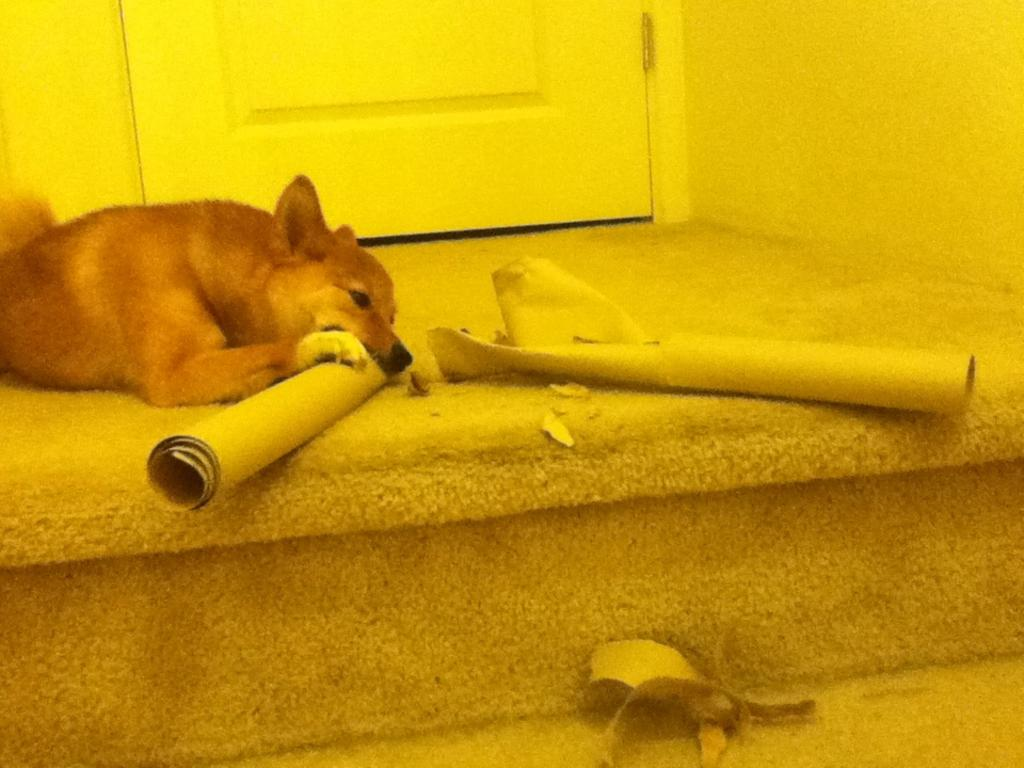What type of animal can be seen in the image? There is a dog in the image. What type of structures are present in the image? There are walls and a door in the image. What else can be found in the image besides the dog and structures? There are objects in the image. How does the dog use the brake in the image? There is no brake present in the image; it is a dog and not a vehicle. What type of bean is being grown in the image? There is no bean plant or any reference to beans in the image. 